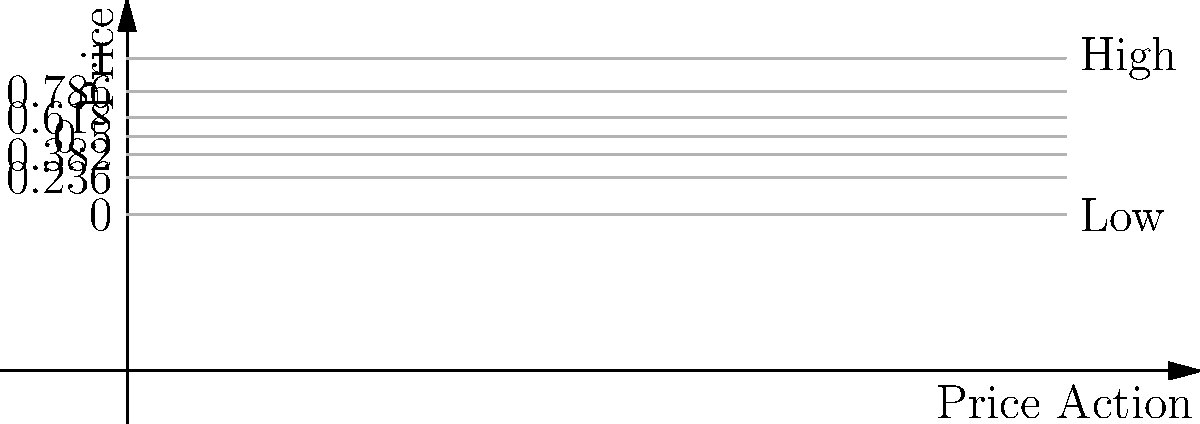On a price chart with a high of $100 and a low of $50, what is the price difference between the 0.382 and 0.618 Fibonacci retracement levels? To solve this problem, we'll follow these steps:

1. Calculate the total price range:
   $\text{Total Range} = \text{High} - \text{Low} = 100 - 50 = 50$

2. Calculate the price at the 0.382 Fibonacci level:
   $\text{Price}_{\text{0.382}} = \text{Low} + (0.382 \times \text{Total Range})$
   $= 50 + (0.382 \times 50) = 50 + 19.1 = 69.1$

3. Calculate the price at the 0.618 Fibonacci level:
   $\text{Price}_{\text{0.618}} = \text{Low} + (0.618 \times \text{Total Range})$
   $= 50 + (0.618 \times 50) = 50 + 30.9 = 80.9$

4. Calculate the difference between these two prices:
   $\text{Difference} = \text{Price}_{\text{0.618}} - \text{Price}_{\text{0.382}}$
   $= 80.9 - 69.1 = 11.8$

Therefore, the price difference between the 0.382 and 0.618 Fibonacci retracement levels is $11.8.
Answer: $11.8 